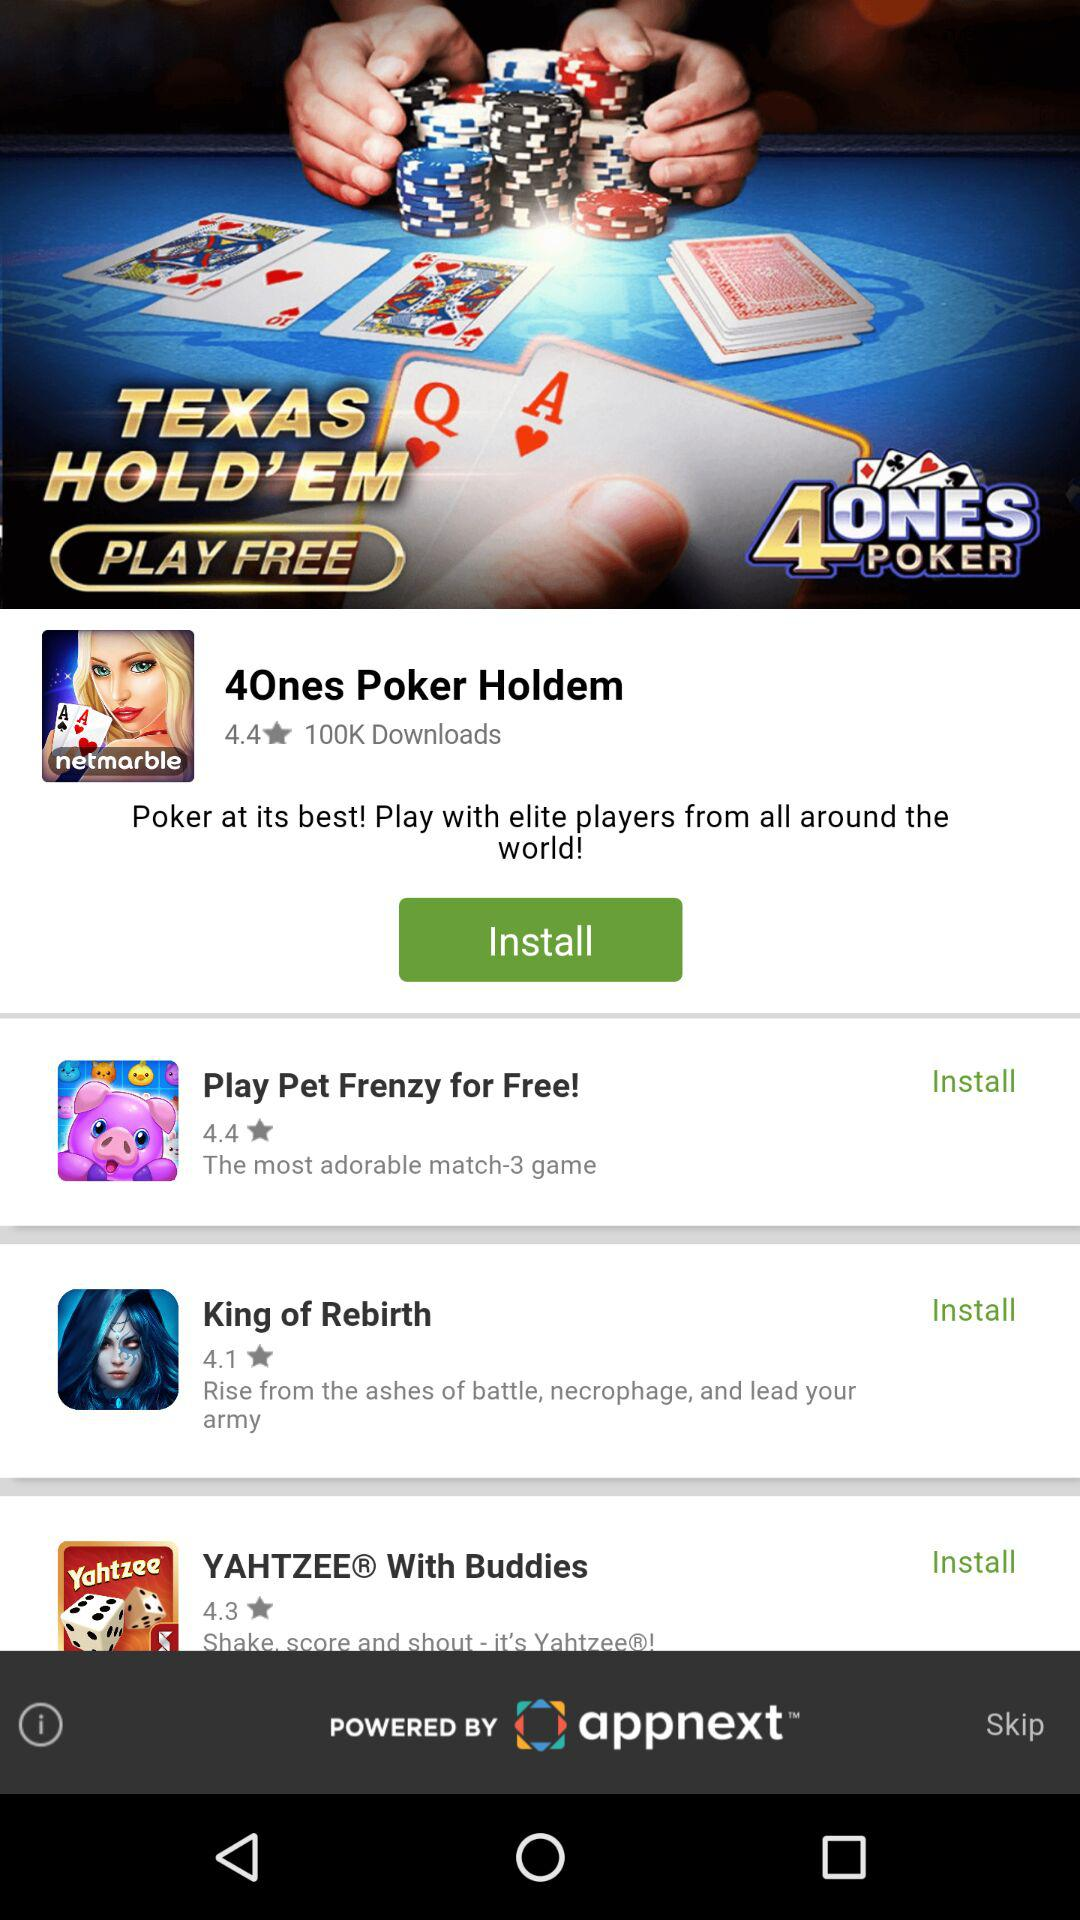What is the rating for "Play Pet Frenzy for Free!"? The rating for "Play Pet Frenzy for Free!" is 4.4. 